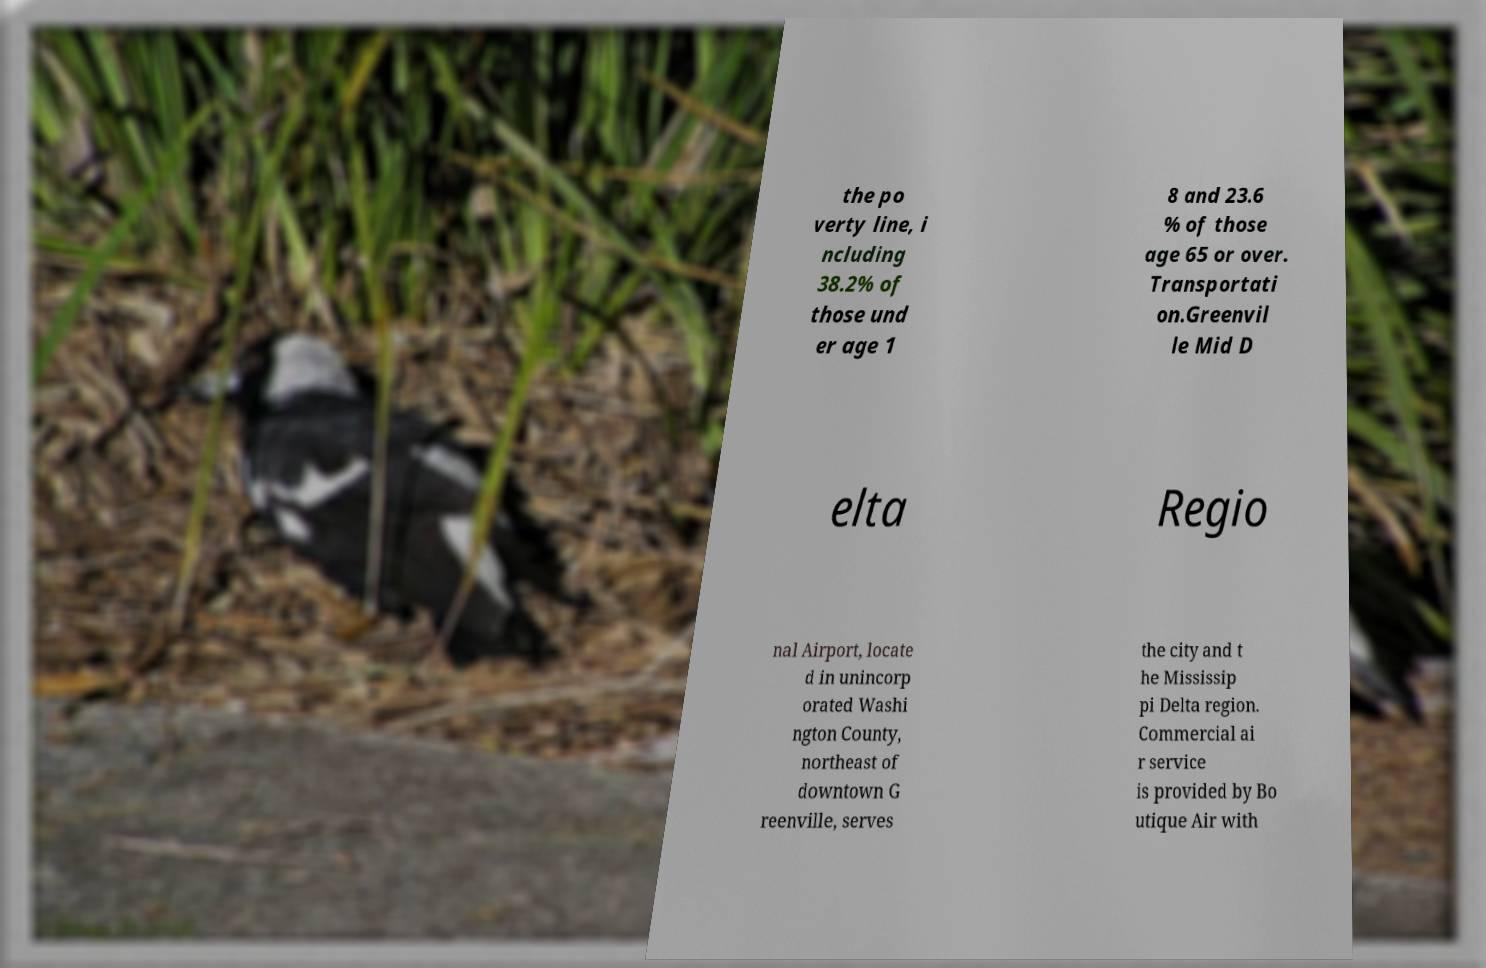Can you accurately transcribe the text from the provided image for me? the po verty line, i ncluding 38.2% of those und er age 1 8 and 23.6 % of those age 65 or over. Transportati on.Greenvil le Mid D elta Regio nal Airport, locate d in unincorp orated Washi ngton County, northeast of downtown G reenville, serves the city and t he Mississip pi Delta region. Commercial ai r service is provided by Bo utique Air with 